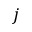<formula> <loc_0><loc_0><loc_500><loc_500>j</formula> 